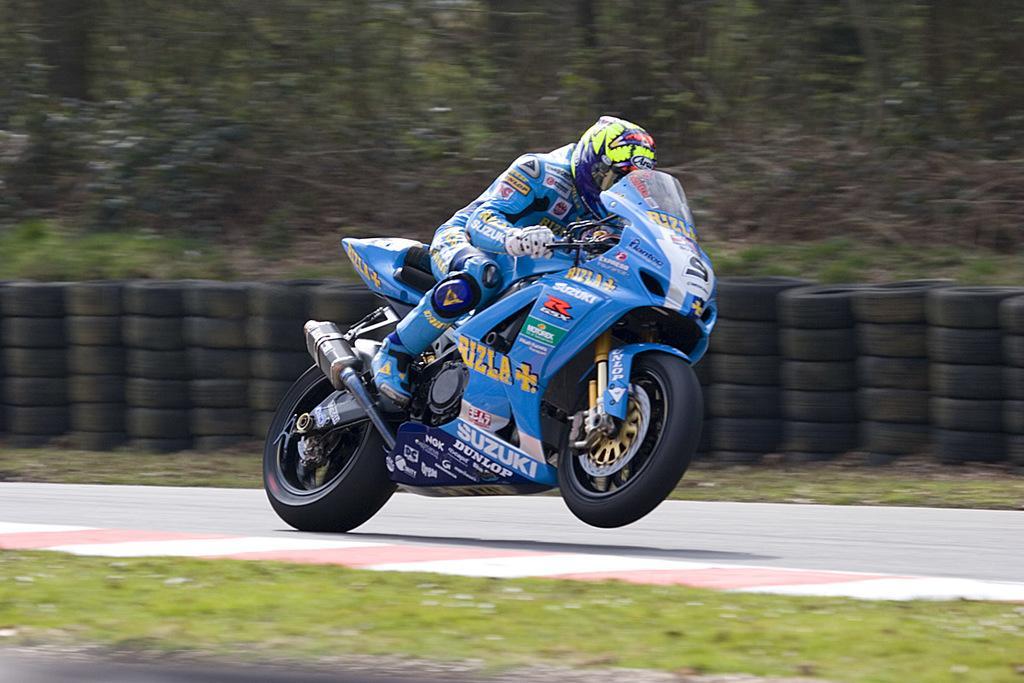Can you describe this image briefly? In this image in the center there is one bike, on that bike there is one person who is sitting and driving. At the bottom there is a road and grass, in the background there are some trees and tires. 